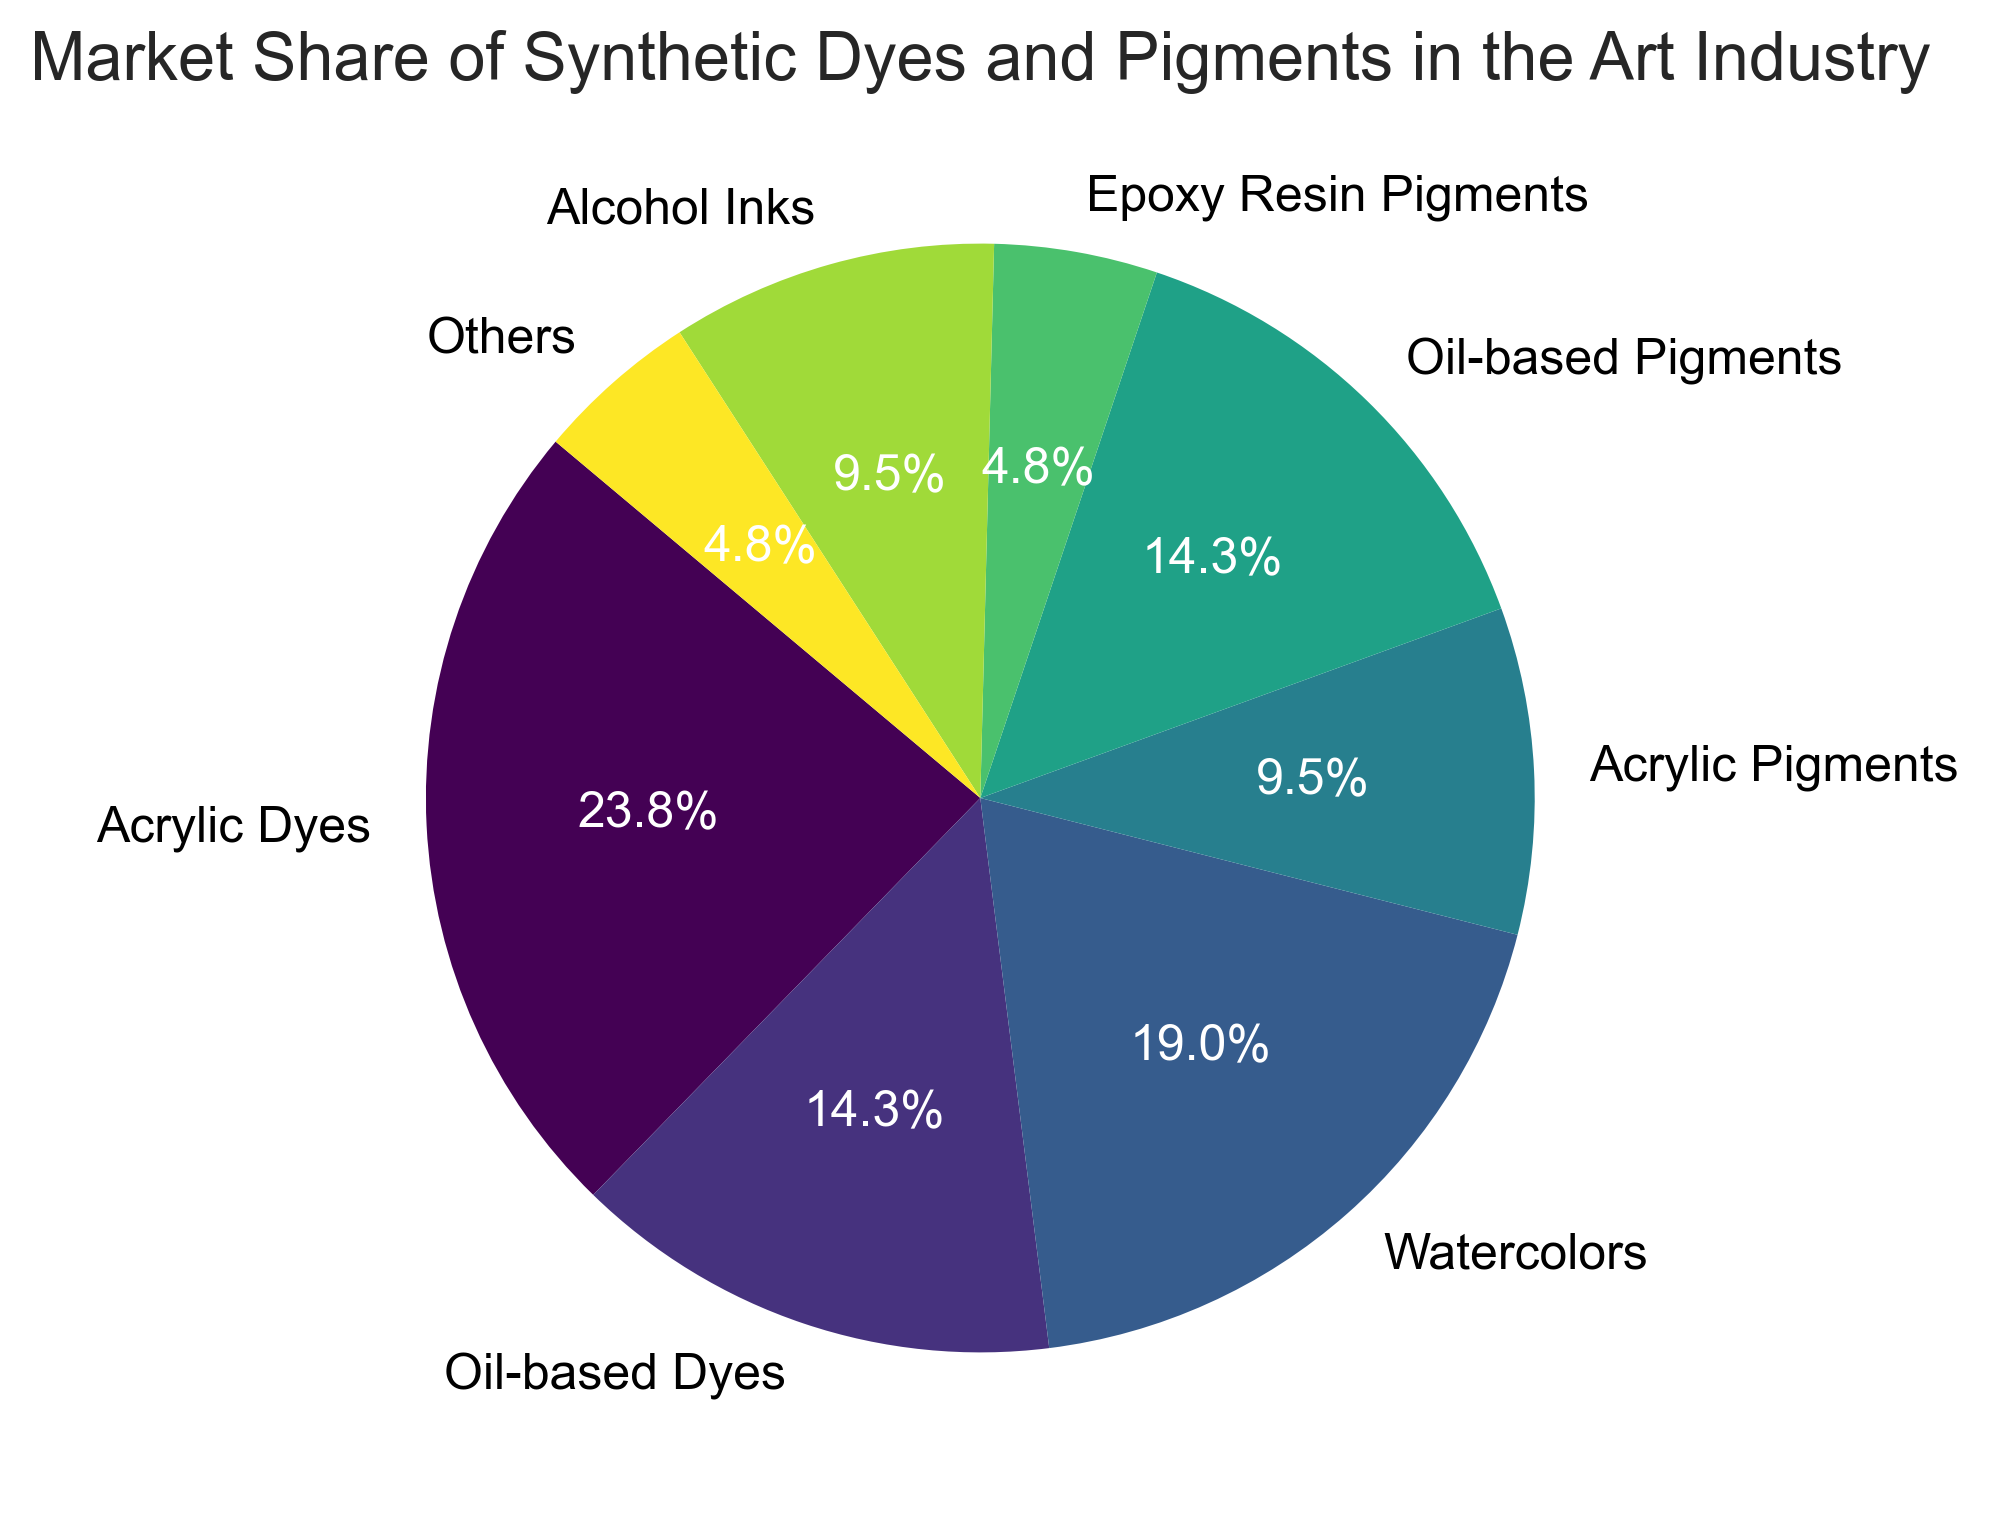What category has the largest market share? By looking at the pie chart, the segment with the largest area represents the largest market share, which is clearly labeled in the chart.
Answer: Acrylic Dyes Which categories collectively make up 50% of the market? By adding up the percentages of categories in descending order, the sum of the market shares for Acrylic Dyes (25%) and Watercolors (20%) reaches 45%. Adding Oil-based Dyes (15%) brings the total to 60%, so we overshoot. Thus, we only need Acrylic Dyes (25%) and Watercolors (20%), Oil-based Pigments (15%) make up a bit more than 50%.
Answer: Acrylic Dyes, Watercolors, and Oil-based Pigments Which category has the smallest market share? By looking at the pie chart, the smallest segment represents the smallest market share, which is labeled on the chart.
Answer: Epoxy Resin Pigments and Others How much larger is the market share of Acrylic Dyes compared to Oil-based Dyes? The market share of Acrylic Dyes is 25%, and the market share of Oil-based Dyes is 15%. The difference can be calculated as 25% - 15% = 10%.
Answer: 10% What is the approximate combined market share of all pigment categories? Sum up the percentages of Acrylic Pigments (10%), Oil-based Pigments (15%), and Epoxy Resin Pigments (5%): 10% + 15% + 5% = 30%.
Answer: 30% What percentage of the market share do synthetic dyes categories (excluding pigments) have? Sum up the percentages of Acrylic Dyes (25%), Oil-based Dyes (15%), Watercolors (20%), and Alcohol Inks (10%): 25% + 15% + 20% + 10% = 70%.
Answer: 70% Which category has the second largest market share? By looking at the pie chart, the second largest segment represents the second largest market share, which is labeled on the chart.
Answer: Watercolors How many categories have a market share of 10% or more? By looking at the pie chart, we count the segments labeled with 10% or more market share: Acrylic Dyes (25%), Oil-based Dyes (15%), Watercolors (20%), Acrylic Pigments (10%), Oil-based Pigments (15%), and Alcohol Inks (10%). This gives us a total of 6 categories.
Answer: 6 What is the total market share of all categories combined? The pie chart represents 100% of the market share, as it is a complete circle divided among all the categories.
Answer: 100% 